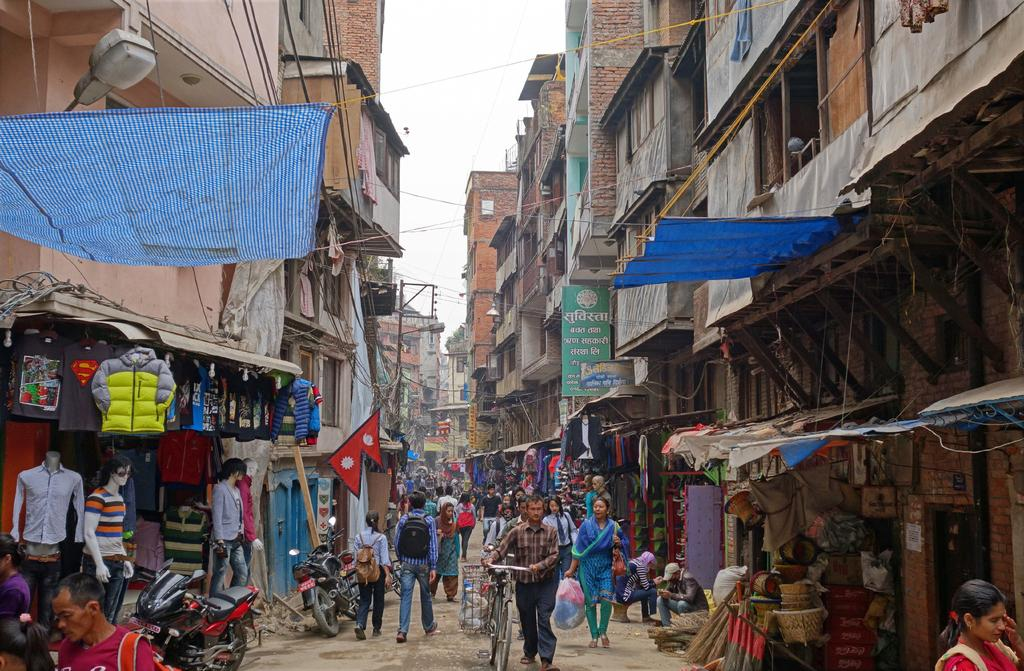How many people are in the image? There are people in the image, but the exact number is not specified. What is the man holding in the image? The man is holding a bicycle. What types of vehicles can be seen in the image? There are vehicles in the image, but the specific types are not mentioned. What kind of establishments are present in the image? There are stores in the image. Can you describe the lighting conditions in the image? There is light visible in the image. What structures are present in the image? There are poles, boards, and buildings in the image. What is the man doing with the cloth and rope in the image? The image shows a man holding a bicycle, but there is no mention of a cloth with a rope. What can be seen in the background of the image? The sky is visible in the background of the image. What is the topic of the discussion taking place among the people in the image? There is no indication of a discussion taking place among the people in the image. What is the condition of the clover growing near the bicycle in the image? There is no clover present in the image. 